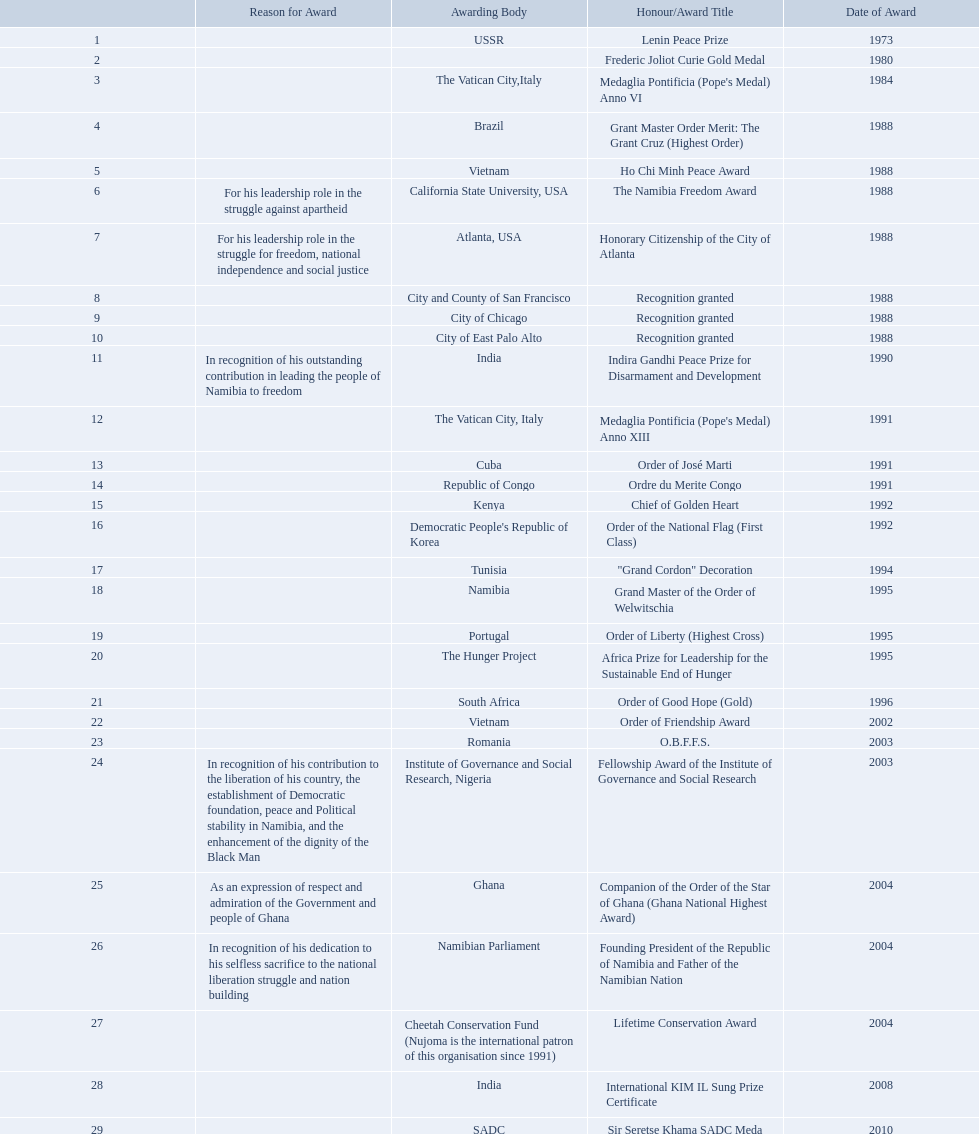What awards did sam nujoma win? 1, 1973, Lenin Peace Prize, Frederic Joliot Curie Gold Medal, Medaglia Pontificia (Pope's Medal) Anno VI, Grant Master Order Merit: The Grant Cruz (Highest Order), Ho Chi Minh Peace Award, The Namibia Freedom Award, Honorary Citizenship of the City of Atlanta, Recognition granted, Recognition granted, Recognition granted, Indira Gandhi Peace Prize for Disarmament and Development, Medaglia Pontificia (Pope's Medal) Anno XIII, Order of José Marti, Ordre du Merite Congo, Chief of Golden Heart, Order of the National Flag (First Class), "Grand Cordon" Decoration, Grand Master of the Order of Welwitschia, Order of Liberty (Highest Cross), Africa Prize for Leadership for the Sustainable End of Hunger, Order of Good Hope (Gold), Order of Friendship Award, O.B.F.F.S., Fellowship Award of the Institute of Governance and Social Research, Companion of the Order of the Star of Ghana (Ghana National Highest Award), Founding President of the Republic of Namibia and Father of the Namibian Nation, Lifetime Conservation Award, International KIM IL Sung Prize Certificate, Sir Seretse Khama SADC Meda. Who was the awarding body for the o.b.f.f.s award? Romania. 